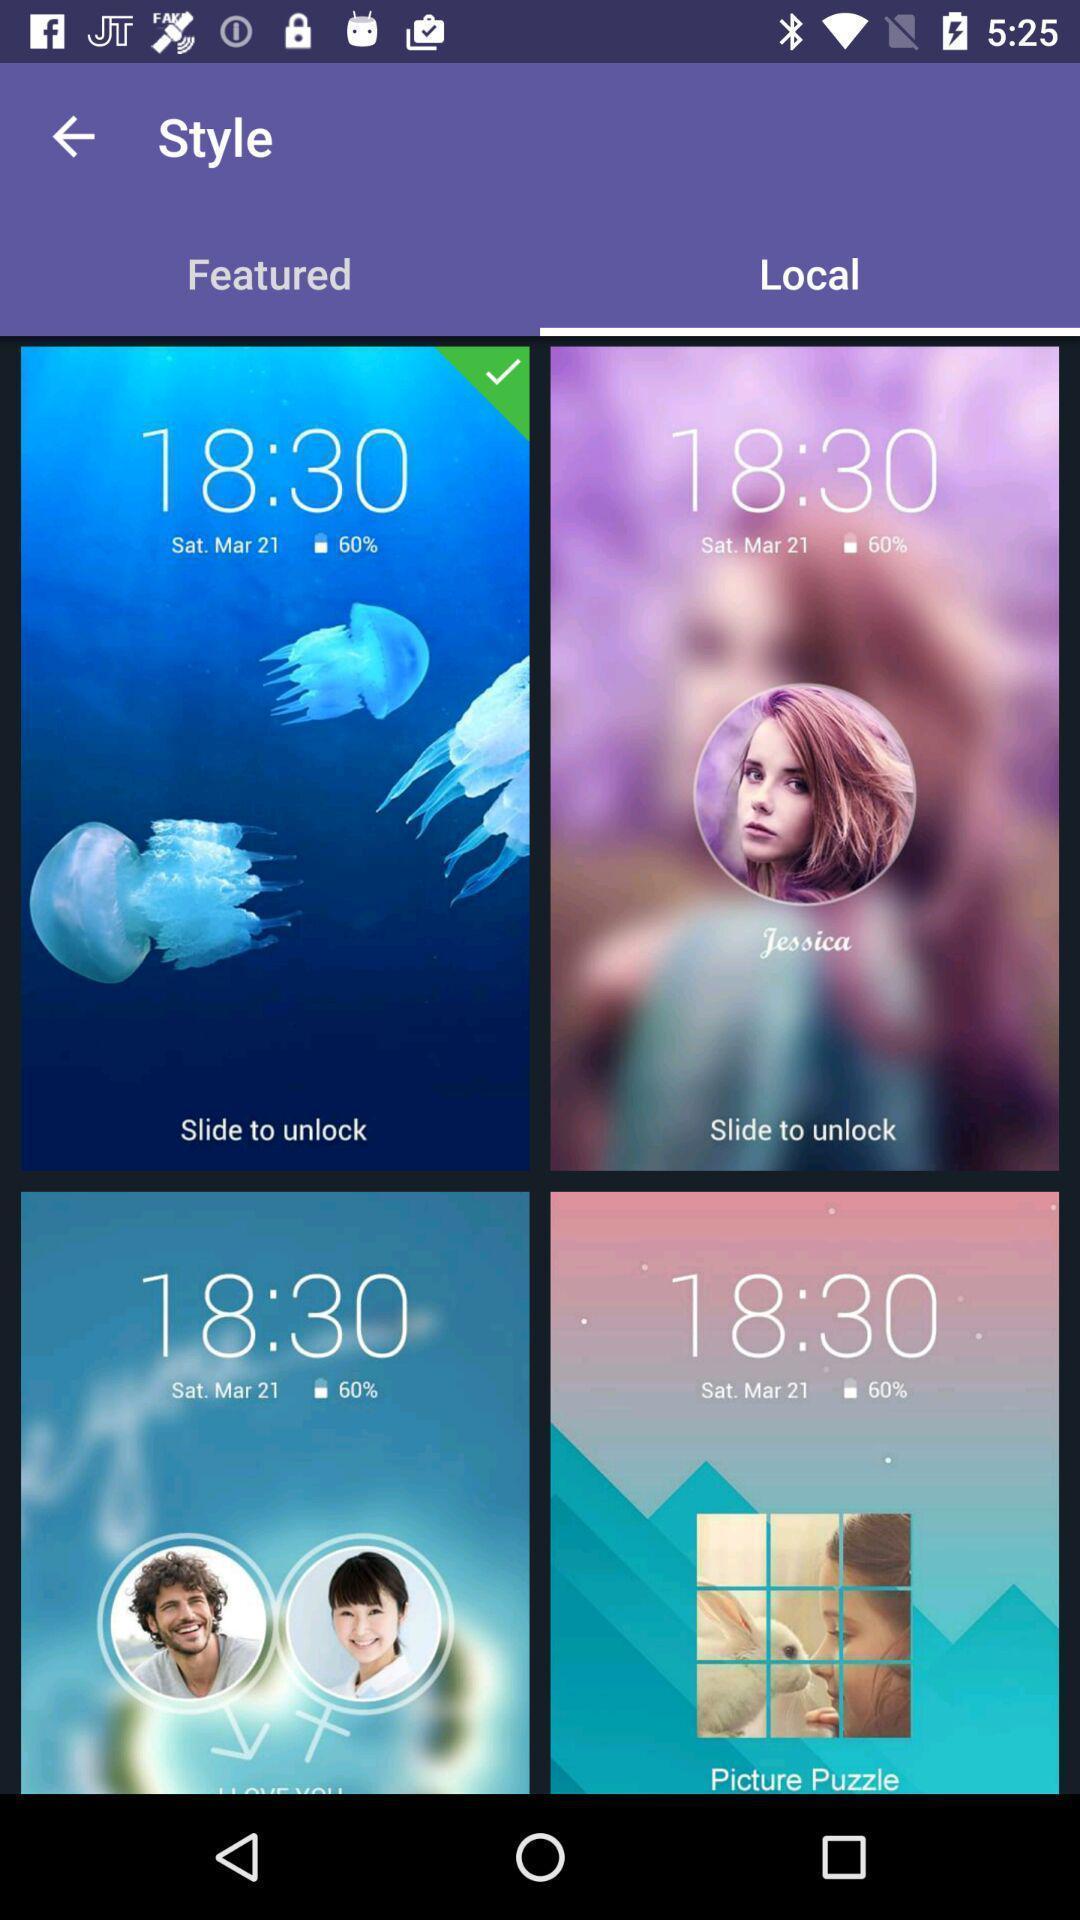Tell me about the visual elements in this screen capture. Page displaying the styles of slides. 